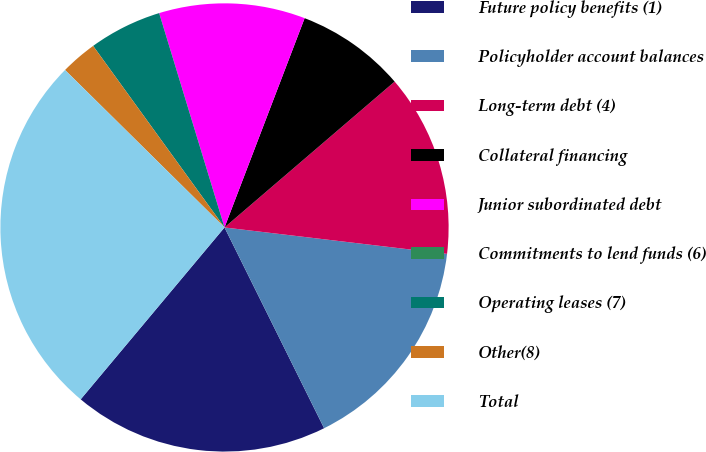Convert chart to OTSL. <chart><loc_0><loc_0><loc_500><loc_500><pie_chart><fcel>Future policy benefits (1)<fcel>Policyholder account balances<fcel>Long-term debt (4)<fcel>Collateral financing<fcel>Junior subordinated debt<fcel>Commitments to lend funds (6)<fcel>Operating leases (7)<fcel>Other(8)<fcel>Total<nl><fcel>18.42%<fcel>15.79%<fcel>13.16%<fcel>7.9%<fcel>10.53%<fcel>0.0%<fcel>5.26%<fcel>2.63%<fcel>26.31%<nl></chart> 